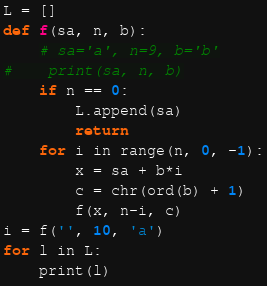<code> <loc_0><loc_0><loc_500><loc_500><_Python_>
L = []
def f(sa, n, b):
    # sa='a', n=9, b='b'
#    print(sa, n, b)
    if n == 0:
        L.append(sa)
        return
    for i in range(n, 0, -1):
        x = sa + b*i
        c = chr(ord(b) + 1)
        f(x, n-i, c)
i = f('', 10, 'a')
for l in L:
    print(l)
</code> 